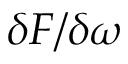Convert formula to latex. <formula><loc_0><loc_0><loc_500><loc_500>\delta F / \delta \omega</formula> 